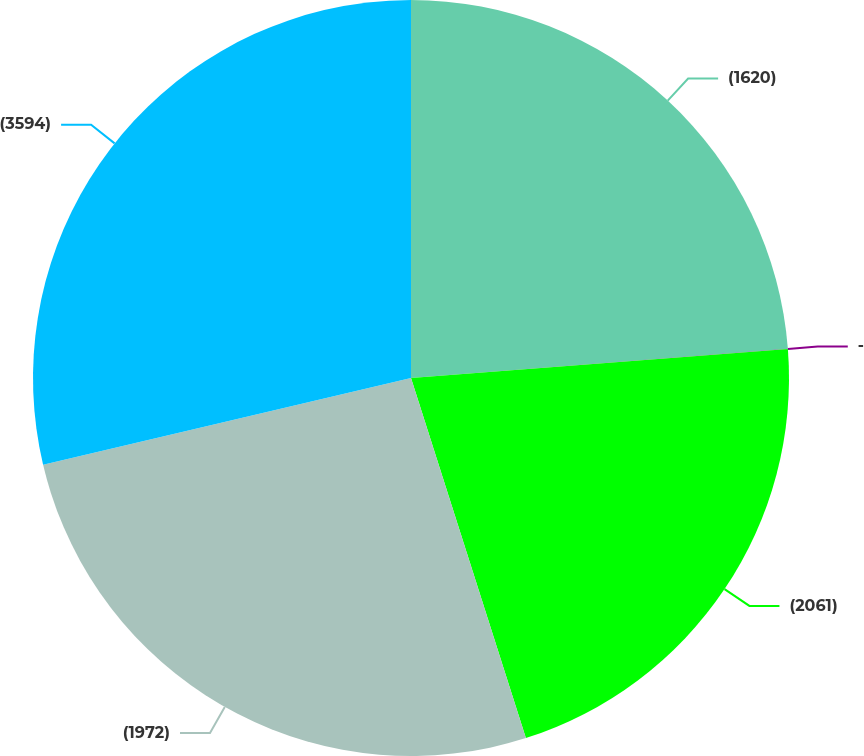Convert chart. <chart><loc_0><loc_0><loc_500><loc_500><pie_chart><fcel>(1620)<fcel>-<fcel>(2061)<fcel>(1972)<fcel>(3594)<nl><fcel>23.77%<fcel>0.01%<fcel>21.31%<fcel>26.23%<fcel>28.69%<nl></chart> 